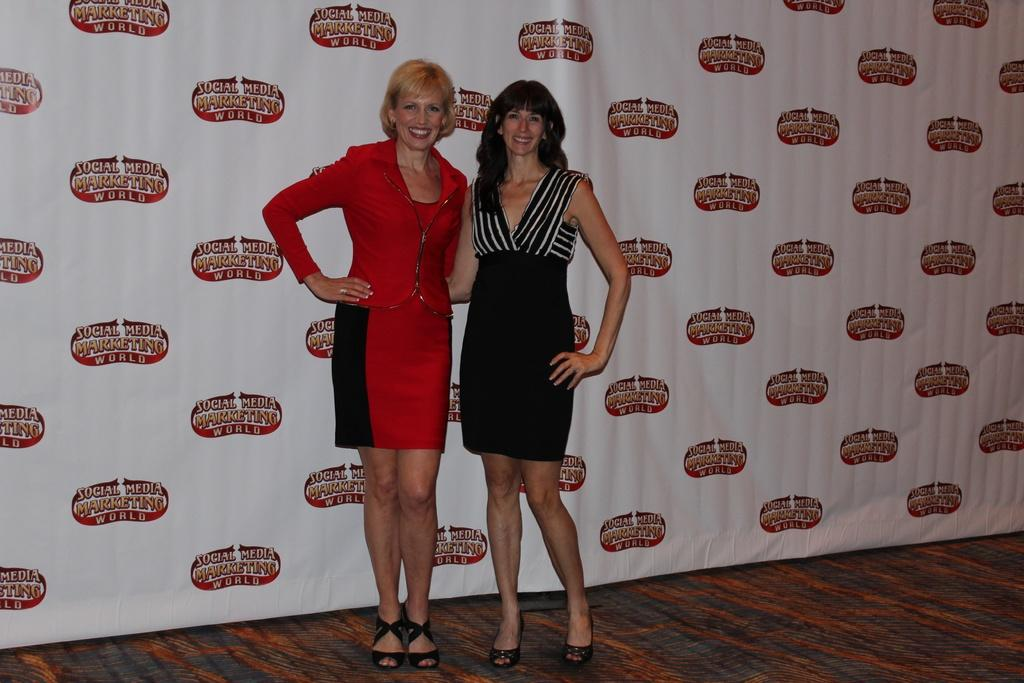How many people are in the image? There are two women in the image. What expressions do the women have? Both women are smiling. What can be seen in the background of the image? There is a hoarding in the background of the image. What flavor of whip is being enjoyed by the family in the image? There is no family present in the image, and no whip can be seen. 